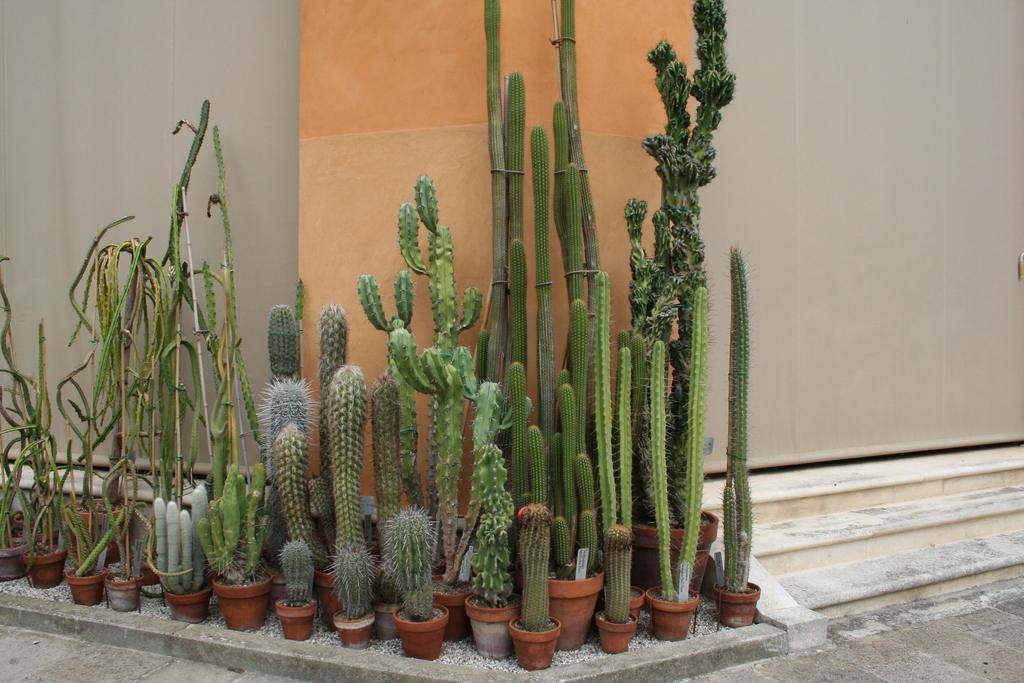How would you summarize this image in a sentence or two? In this picture we can see different kinds of plants on a flower pot and some of the plants such as cacti this all are placed beside the steps of a building. 